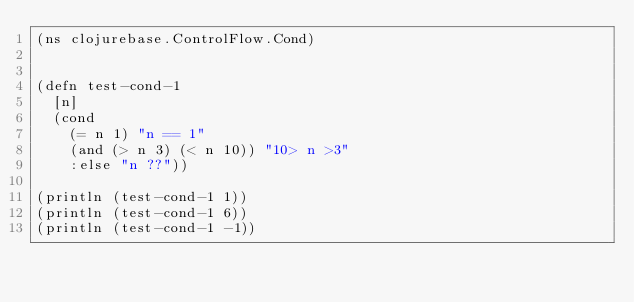Convert code to text. <code><loc_0><loc_0><loc_500><loc_500><_Clojure_>(ns clojurebase.ControlFlow.Cond)


(defn test-cond-1
  [n]
  (cond
    (= n 1) "n == 1"
    (and (> n 3) (< n 10)) "10> n >3"
    :else "n ??"))

(println (test-cond-1 1))
(println (test-cond-1 6))
(println (test-cond-1 -1))</code> 